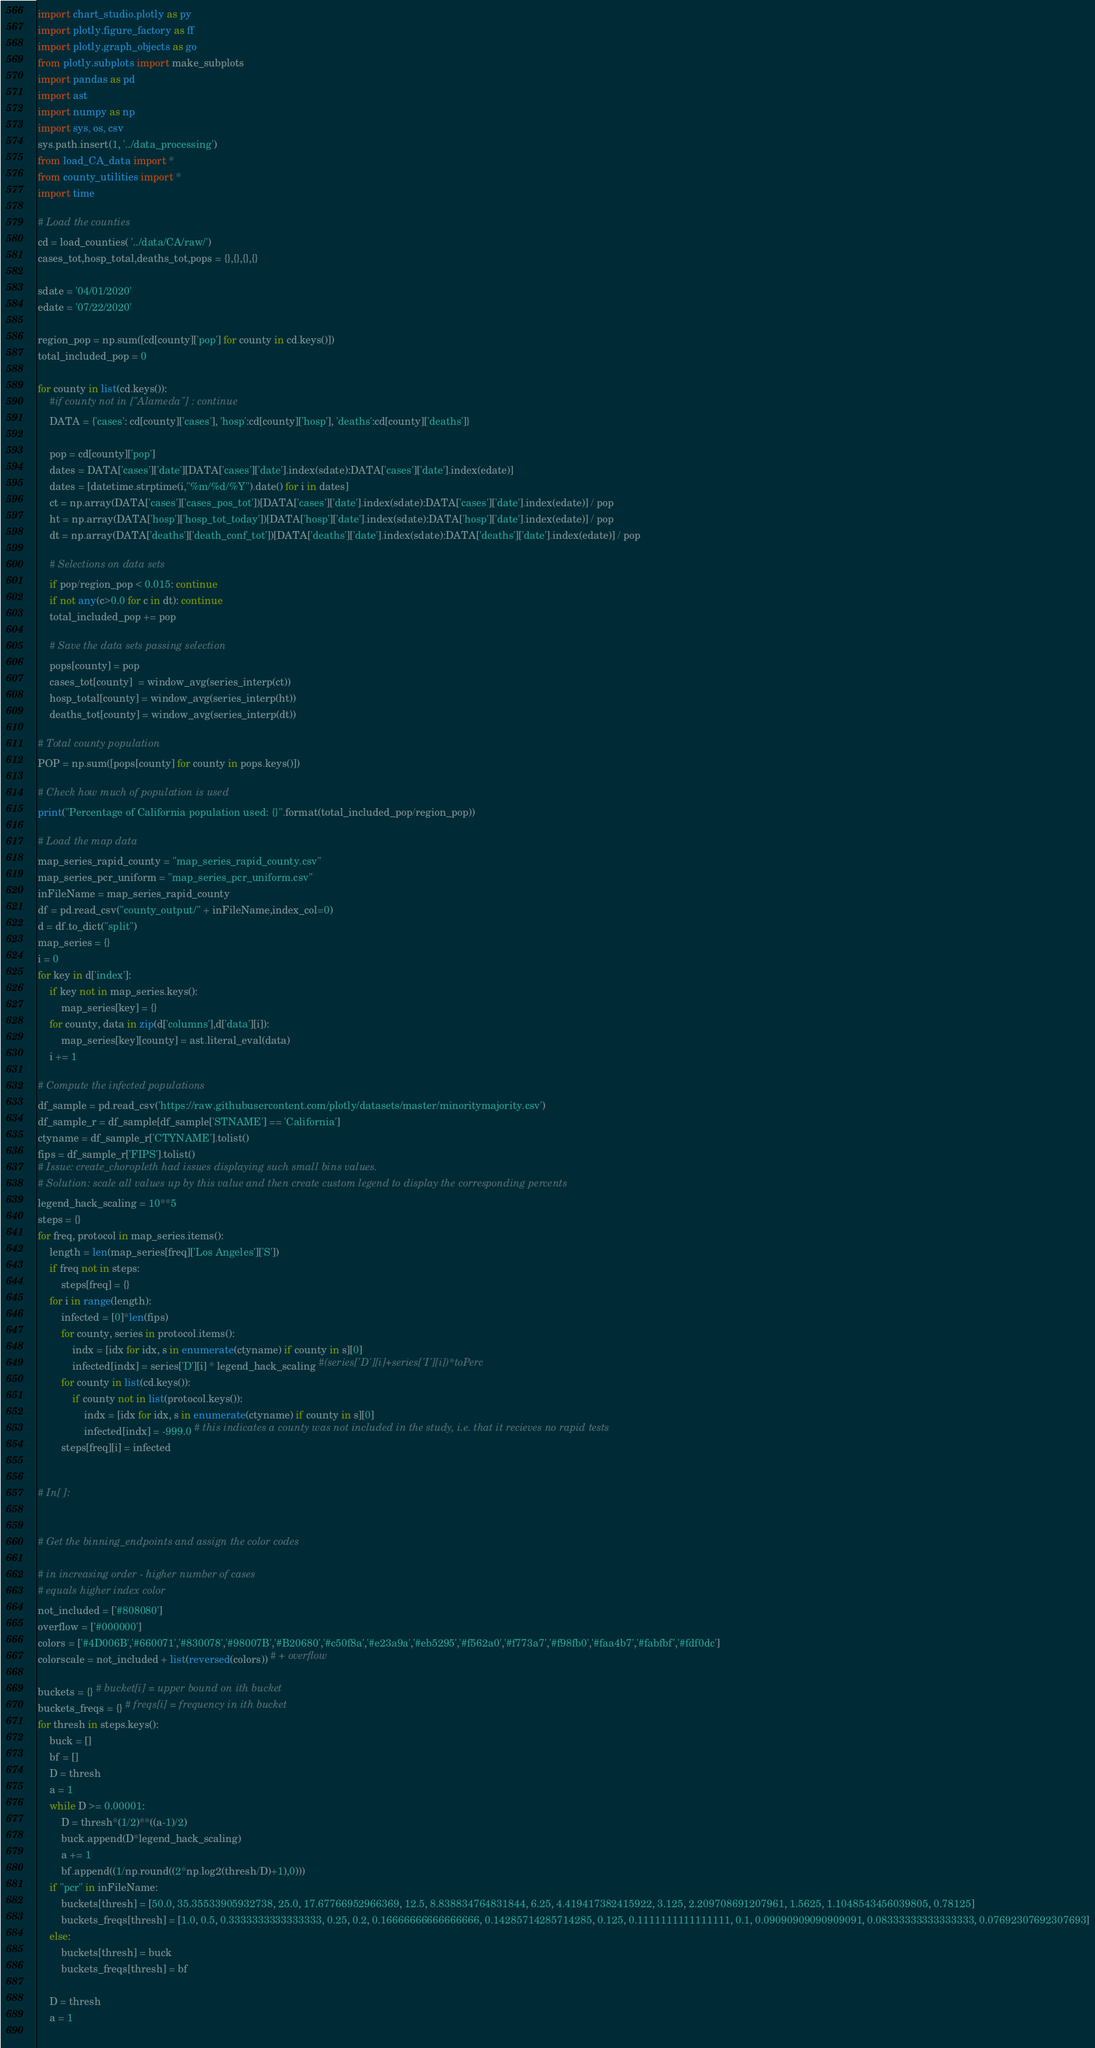Convert code to text. <code><loc_0><loc_0><loc_500><loc_500><_Python_>import chart_studio.plotly as py
import plotly.figure_factory as ff
import plotly.graph_objects as go
from plotly.subplots import make_subplots
import pandas as pd
import ast
import numpy as np
import sys, os, csv
sys.path.insert(1, '../data_processing')
from load_CA_data import *
from county_utilities import *
import time

# Load the counties 
cd = load_counties( '../data/CA/raw/')
cases_tot,hosp_total,deaths_tot,pops = {},{},{},{}

sdate = '04/01/2020' 
edate = '07/22/2020'

region_pop = np.sum([cd[county]['pop'] for county in cd.keys()])
total_included_pop = 0

for county in list(cd.keys()):
    #if county not in ["Alameda"] : continue
    DATA = {'cases': cd[county]['cases'], 'hosp':cd[county]['hosp'], 'deaths':cd[county]['deaths']}

    pop = cd[county]['pop'] 
    dates = DATA['cases']['date'][DATA['cases']['date'].index(sdate):DATA['cases']['date'].index(edate)]
    dates = [datetime.strptime(i,"%m/%d/%Y").date() for i in dates]
    ct = np.array(DATA['cases']['cases_pos_tot'])[DATA['cases']['date'].index(sdate):DATA['cases']['date'].index(edate)] / pop
    ht = np.array(DATA['hosp']['hosp_tot_today'])[DATA['hosp']['date'].index(sdate):DATA['hosp']['date'].index(edate)] / pop
    dt = np.array(DATA['deaths']['death_conf_tot'])[DATA['deaths']['date'].index(sdate):DATA['deaths']['date'].index(edate)] / pop

    # Selections on data sets
    if pop/region_pop < 0.015: continue 
    if not any(c>0.0 for c in dt): continue
    total_included_pop += pop
    
    # Save the data sets passing selection
    pops[county] = pop
    cases_tot[county]  = window_avg(series_interp(ct))
    hosp_total[county] = window_avg(series_interp(ht))
    deaths_tot[county] = window_avg(series_interp(dt))

# Total county population
POP = np.sum([pops[county] for county in pops.keys()])

# Check how much of population is used
print("Percentage of California population used: {}".format(total_included_pop/region_pop))

# Load the map data
map_series_rapid_county = "map_series_rapid_county.csv"
map_series_pcr_uniform = "map_series_pcr_uniform.csv" 
inFileName = map_series_rapid_county
df = pd.read_csv("county_output/" + inFileName,index_col=0)
d = df.to_dict("split")
map_series = {}
i = 0
for key in d['index']:
    if key not in map_series.keys():
        map_series[key] = {}
    for county, data in zip(d['columns'],d['data'][i]):
        map_series[key][county] = ast.literal_eval(data) 
    i += 1

# Compute the infected populations
df_sample = pd.read_csv('https://raw.githubusercontent.com/plotly/datasets/master/minoritymajority.csv')
df_sample_r = df_sample[df_sample['STNAME'] == 'California']
ctyname = df_sample_r['CTYNAME'].tolist()
fips = df_sample_r['FIPS'].tolist()
# Issue: create_choropleth had issues displaying such small bins values. 
# Solution: scale all values up by this value and then create custom legend to display the corresponding percents
legend_hack_scaling = 10**5 
steps = {}
for freq, protocol in map_series.items():
    length = len(map_series[freq]['Los Angeles']['S'])
    if freq not in steps:
        steps[freq] = {}
    for i in range(length):
        infected = [0]*len(fips)
        for county, series in protocol.items():
            indx = [idx for idx, s in enumerate(ctyname) if county in s][0]
            infected[indx] = series['D'][i] * legend_hack_scaling #(series['D'][i]+series['I'][i])*toPerc 
        for county in list(cd.keys()):
            if county not in list(protocol.keys()):
                indx = [idx for idx, s in enumerate(ctyname) if county in s][0]
                infected[indx] = -999.0 # this indicates a county was not included in the study, i.e. that it recieves no rapid tests
        steps[freq][i] = infected


# In[ ]:


# Get the binning_endpoints and assign the color codes

# in increasing order - higher number of cases
# equals higher index color
not_included = ['#808080']
overflow = ['#000000']
colors = ['#4D006B','#660071','#830078','#98007B','#B20680','#c50f8a','#e23a9a','#eb5295','#f562a0','#f773a7','#f98fb0','#faa4b7','#fabfbf','#fdf0dc'] 
colorscale = not_included + list(reversed(colors)) # + overflow

buckets = {} # bucket[i] = upper bound on ith bucket
buckets_freqs = {} # freqs[i] = frequency in ith bucket
for thresh in steps.keys():
    buck = []
    bf = []
    D = thresh
    a = 1
    while D >= 0.00001:
        D = thresh*(1/2)**((a-1)/2)
        buck.append(D*legend_hack_scaling)
        a += 1
        bf.append((1/np.round((2*np.log2(thresh/D)+1),0)))
    if "pcr" in inFileName:
        buckets[thresh] = [50.0, 35.35533905932738, 25.0, 17.67766952966369, 12.5, 8.838834764831844, 6.25, 4.419417382415922, 3.125, 2.209708691207961, 1.5625, 1.1048543456039805, 0.78125]
        buckets_freqs[thresh] = [1.0, 0.5, 0.3333333333333333, 0.25, 0.2, 0.16666666666666666, 0.14285714285714285, 0.125, 0.1111111111111111, 0.1, 0.09090909090909091, 0.08333333333333333, 0.07692307692307693]
    else: 
        buckets[thresh] = buck
        buckets_freqs[thresh] = bf

    D = thresh
    a = 1
 </code> 